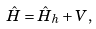<formula> <loc_0><loc_0><loc_500><loc_500>\hat { H } = \hat { H } _ { h } + V ,</formula> 